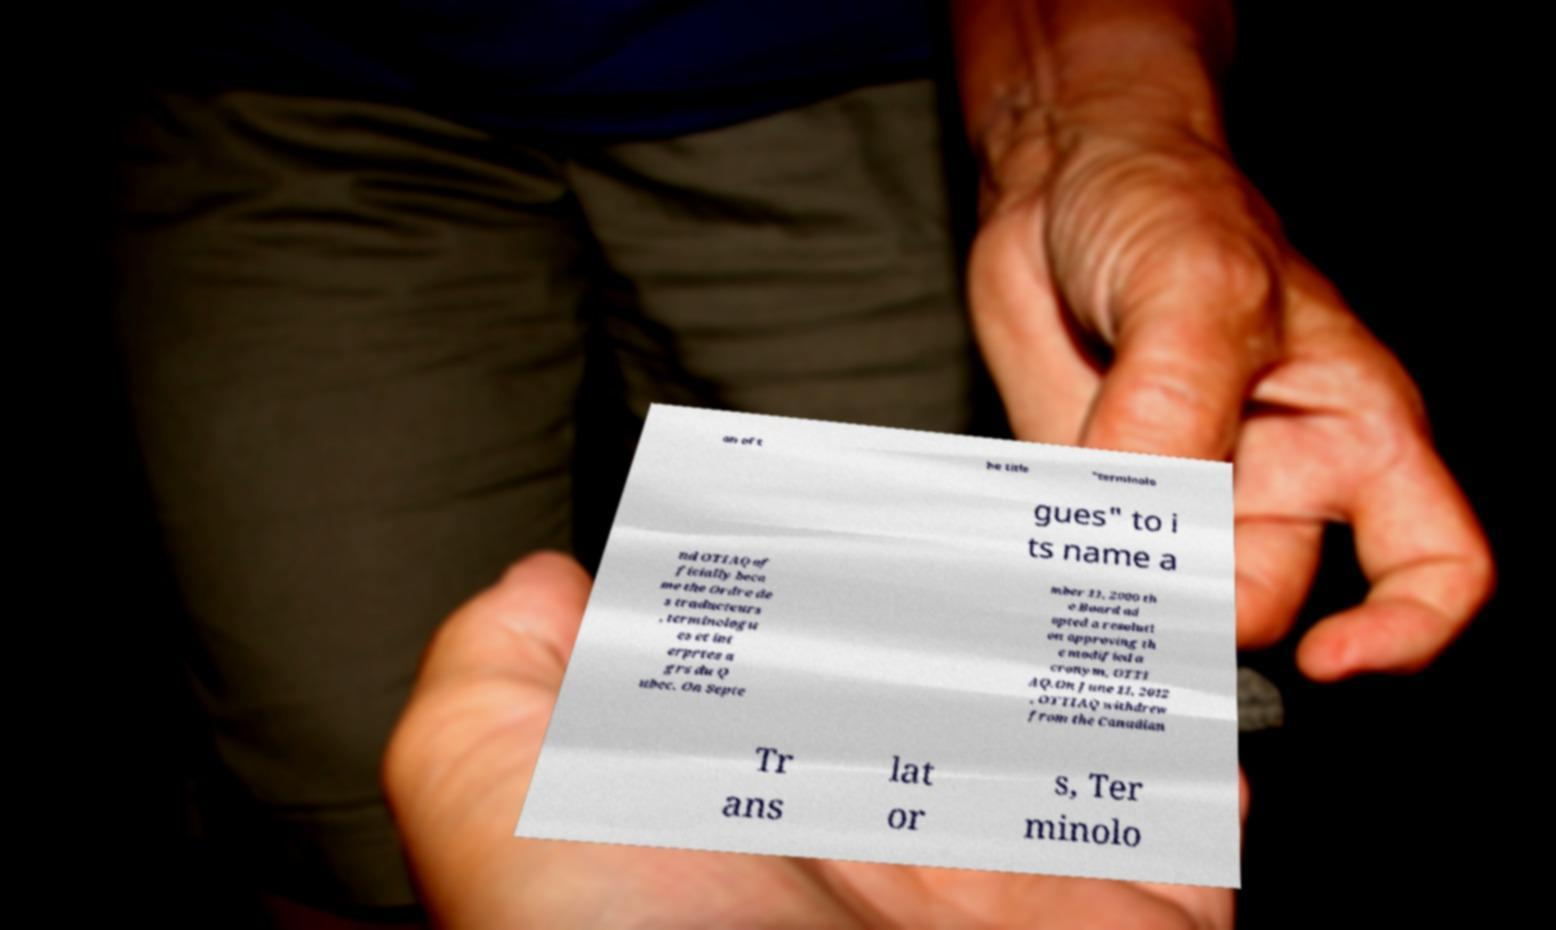Can you read and provide the text displayed in the image?This photo seems to have some interesting text. Can you extract and type it out for me? on of t he title "terminolo gues" to i ts name a nd OTIAQ of ficially beca me the Ordre de s traducteurs , terminologu es et int erprtes a grs du Q ubec. On Septe mber 11, 2000 th e Board ad opted a resoluti on approving th e modified a cronym, OTTI AQ.On June 11, 2012 , OTTIAQ withdrew from the Canadian Tr ans lat or s, Ter minolo 